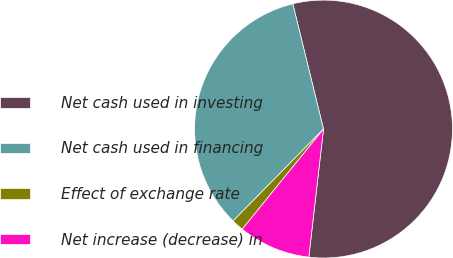<chart> <loc_0><loc_0><loc_500><loc_500><pie_chart><fcel>Net cash used in investing<fcel>Net cash used in financing<fcel>Effect of exchange rate<fcel>Net increase (decrease) in<nl><fcel>55.64%<fcel>33.8%<fcel>1.52%<fcel>9.03%<nl></chart> 